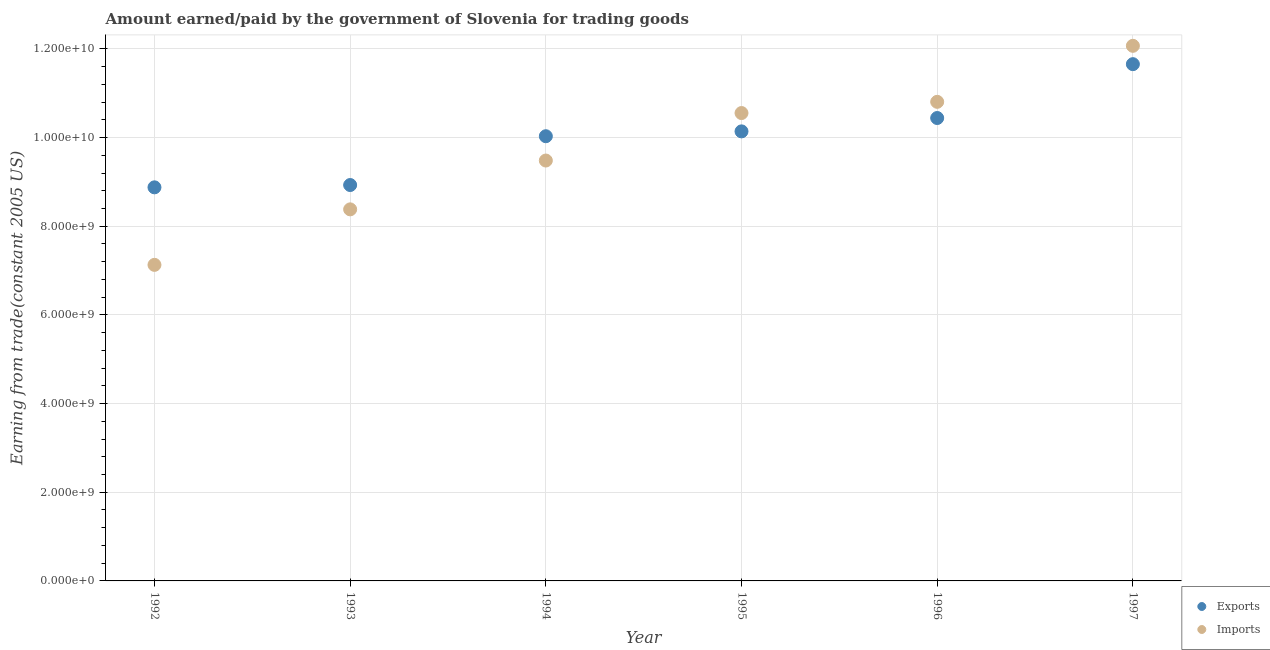How many different coloured dotlines are there?
Provide a succinct answer. 2. What is the amount earned from exports in 1997?
Keep it short and to the point. 1.17e+1. Across all years, what is the maximum amount paid for imports?
Offer a very short reply. 1.21e+1. Across all years, what is the minimum amount paid for imports?
Give a very brief answer. 7.13e+09. In which year was the amount earned from exports maximum?
Your answer should be compact. 1997. What is the total amount paid for imports in the graph?
Make the answer very short. 5.84e+1. What is the difference between the amount paid for imports in 1992 and that in 1994?
Provide a short and direct response. -2.35e+09. What is the difference between the amount earned from exports in 1993 and the amount paid for imports in 1992?
Your response must be concise. 1.80e+09. What is the average amount paid for imports per year?
Keep it short and to the point. 9.74e+09. In the year 1996, what is the difference between the amount paid for imports and amount earned from exports?
Keep it short and to the point. 3.65e+08. In how many years, is the amount paid for imports greater than 5600000000 US$?
Provide a succinct answer. 6. What is the ratio of the amount paid for imports in 1993 to that in 1994?
Give a very brief answer. 0.88. Is the amount paid for imports in 1992 less than that in 1995?
Provide a succinct answer. Yes. Is the difference between the amount earned from exports in 1995 and 1997 greater than the difference between the amount paid for imports in 1995 and 1997?
Offer a terse response. Yes. What is the difference between the highest and the second highest amount earned from exports?
Offer a very short reply. 1.21e+09. What is the difference between the highest and the lowest amount earned from exports?
Offer a terse response. 2.78e+09. Is the sum of the amount paid for imports in 1992 and 1993 greater than the maximum amount earned from exports across all years?
Your answer should be compact. Yes. Is the amount paid for imports strictly less than the amount earned from exports over the years?
Your response must be concise. No. How many dotlines are there?
Provide a short and direct response. 2. How many years are there in the graph?
Provide a short and direct response. 6. What is the difference between two consecutive major ticks on the Y-axis?
Your response must be concise. 2.00e+09. Are the values on the major ticks of Y-axis written in scientific E-notation?
Offer a very short reply. Yes. What is the title of the graph?
Keep it short and to the point. Amount earned/paid by the government of Slovenia for trading goods. What is the label or title of the X-axis?
Your response must be concise. Year. What is the label or title of the Y-axis?
Provide a succinct answer. Earning from trade(constant 2005 US). What is the Earning from trade(constant 2005 US) in Exports in 1992?
Provide a succinct answer. 8.88e+09. What is the Earning from trade(constant 2005 US) of Imports in 1992?
Offer a terse response. 7.13e+09. What is the Earning from trade(constant 2005 US) of Exports in 1993?
Ensure brevity in your answer.  8.93e+09. What is the Earning from trade(constant 2005 US) in Imports in 1993?
Ensure brevity in your answer.  8.38e+09. What is the Earning from trade(constant 2005 US) of Exports in 1994?
Provide a succinct answer. 1.00e+1. What is the Earning from trade(constant 2005 US) of Imports in 1994?
Offer a terse response. 9.48e+09. What is the Earning from trade(constant 2005 US) of Exports in 1995?
Offer a terse response. 1.01e+1. What is the Earning from trade(constant 2005 US) in Imports in 1995?
Provide a short and direct response. 1.06e+1. What is the Earning from trade(constant 2005 US) of Exports in 1996?
Make the answer very short. 1.04e+1. What is the Earning from trade(constant 2005 US) of Imports in 1996?
Your answer should be compact. 1.08e+1. What is the Earning from trade(constant 2005 US) of Exports in 1997?
Your answer should be compact. 1.17e+1. What is the Earning from trade(constant 2005 US) in Imports in 1997?
Keep it short and to the point. 1.21e+1. Across all years, what is the maximum Earning from trade(constant 2005 US) of Exports?
Ensure brevity in your answer.  1.17e+1. Across all years, what is the maximum Earning from trade(constant 2005 US) in Imports?
Offer a terse response. 1.21e+1. Across all years, what is the minimum Earning from trade(constant 2005 US) of Exports?
Offer a terse response. 8.88e+09. Across all years, what is the minimum Earning from trade(constant 2005 US) in Imports?
Make the answer very short. 7.13e+09. What is the total Earning from trade(constant 2005 US) of Exports in the graph?
Offer a very short reply. 6.01e+1. What is the total Earning from trade(constant 2005 US) of Imports in the graph?
Offer a terse response. 5.84e+1. What is the difference between the Earning from trade(constant 2005 US) in Exports in 1992 and that in 1993?
Offer a very short reply. -5.21e+07. What is the difference between the Earning from trade(constant 2005 US) of Imports in 1992 and that in 1993?
Give a very brief answer. -1.25e+09. What is the difference between the Earning from trade(constant 2005 US) of Exports in 1992 and that in 1994?
Ensure brevity in your answer.  -1.15e+09. What is the difference between the Earning from trade(constant 2005 US) of Imports in 1992 and that in 1994?
Your answer should be very brief. -2.35e+09. What is the difference between the Earning from trade(constant 2005 US) in Exports in 1992 and that in 1995?
Offer a very short reply. -1.26e+09. What is the difference between the Earning from trade(constant 2005 US) in Imports in 1992 and that in 1995?
Your answer should be compact. -3.42e+09. What is the difference between the Earning from trade(constant 2005 US) of Exports in 1992 and that in 1996?
Offer a terse response. -1.56e+09. What is the difference between the Earning from trade(constant 2005 US) of Imports in 1992 and that in 1996?
Make the answer very short. -3.68e+09. What is the difference between the Earning from trade(constant 2005 US) in Exports in 1992 and that in 1997?
Your answer should be compact. -2.78e+09. What is the difference between the Earning from trade(constant 2005 US) in Imports in 1992 and that in 1997?
Offer a very short reply. -4.94e+09. What is the difference between the Earning from trade(constant 2005 US) in Exports in 1993 and that in 1994?
Provide a short and direct response. -1.10e+09. What is the difference between the Earning from trade(constant 2005 US) of Imports in 1993 and that in 1994?
Make the answer very short. -1.10e+09. What is the difference between the Earning from trade(constant 2005 US) in Exports in 1993 and that in 1995?
Your answer should be very brief. -1.21e+09. What is the difference between the Earning from trade(constant 2005 US) in Imports in 1993 and that in 1995?
Provide a short and direct response. -2.17e+09. What is the difference between the Earning from trade(constant 2005 US) of Exports in 1993 and that in 1996?
Offer a terse response. -1.51e+09. What is the difference between the Earning from trade(constant 2005 US) in Imports in 1993 and that in 1996?
Ensure brevity in your answer.  -2.43e+09. What is the difference between the Earning from trade(constant 2005 US) of Exports in 1993 and that in 1997?
Your answer should be very brief. -2.73e+09. What is the difference between the Earning from trade(constant 2005 US) in Imports in 1993 and that in 1997?
Your response must be concise. -3.69e+09. What is the difference between the Earning from trade(constant 2005 US) in Exports in 1994 and that in 1995?
Give a very brief answer. -1.09e+08. What is the difference between the Earning from trade(constant 2005 US) in Imports in 1994 and that in 1995?
Give a very brief answer. -1.07e+09. What is the difference between the Earning from trade(constant 2005 US) of Exports in 1994 and that in 1996?
Provide a succinct answer. -4.11e+08. What is the difference between the Earning from trade(constant 2005 US) of Imports in 1994 and that in 1996?
Offer a terse response. -1.32e+09. What is the difference between the Earning from trade(constant 2005 US) in Exports in 1994 and that in 1997?
Ensure brevity in your answer.  -1.63e+09. What is the difference between the Earning from trade(constant 2005 US) of Imports in 1994 and that in 1997?
Provide a short and direct response. -2.59e+09. What is the difference between the Earning from trade(constant 2005 US) in Exports in 1995 and that in 1996?
Your answer should be very brief. -3.01e+08. What is the difference between the Earning from trade(constant 2005 US) in Imports in 1995 and that in 1996?
Provide a succinct answer. -2.53e+08. What is the difference between the Earning from trade(constant 2005 US) in Exports in 1995 and that in 1997?
Provide a short and direct response. -1.52e+09. What is the difference between the Earning from trade(constant 2005 US) in Imports in 1995 and that in 1997?
Your answer should be compact. -1.52e+09. What is the difference between the Earning from trade(constant 2005 US) of Exports in 1996 and that in 1997?
Your answer should be very brief. -1.21e+09. What is the difference between the Earning from trade(constant 2005 US) in Imports in 1996 and that in 1997?
Make the answer very short. -1.26e+09. What is the difference between the Earning from trade(constant 2005 US) in Exports in 1992 and the Earning from trade(constant 2005 US) in Imports in 1993?
Offer a terse response. 4.97e+08. What is the difference between the Earning from trade(constant 2005 US) in Exports in 1992 and the Earning from trade(constant 2005 US) in Imports in 1994?
Ensure brevity in your answer.  -6.05e+08. What is the difference between the Earning from trade(constant 2005 US) in Exports in 1992 and the Earning from trade(constant 2005 US) in Imports in 1995?
Offer a terse response. -1.68e+09. What is the difference between the Earning from trade(constant 2005 US) in Exports in 1992 and the Earning from trade(constant 2005 US) in Imports in 1996?
Make the answer very short. -1.93e+09. What is the difference between the Earning from trade(constant 2005 US) in Exports in 1992 and the Earning from trade(constant 2005 US) in Imports in 1997?
Your answer should be very brief. -3.19e+09. What is the difference between the Earning from trade(constant 2005 US) in Exports in 1993 and the Earning from trade(constant 2005 US) in Imports in 1994?
Ensure brevity in your answer.  -5.52e+08. What is the difference between the Earning from trade(constant 2005 US) of Exports in 1993 and the Earning from trade(constant 2005 US) of Imports in 1995?
Ensure brevity in your answer.  -1.62e+09. What is the difference between the Earning from trade(constant 2005 US) in Exports in 1993 and the Earning from trade(constant 2005 US) in Imports in 1996?
Your response must be concise. -1.88e+09. What is the difference between the Earning from trade(constant 2005 US) in Exports in 1993 and the Earning from trade(constant 2005 US) in Imports in 1997?
Your answer should be compact. -3.14e+09. What is the difference between the Earning from trade(constant 2005 US) of Exports in 1994 and the Earning from trade(constant 2005 US) of Imports in 1995?
Keep it short and to the point. -5.23e+08. What is the difference between the Earning from trade(constant 2005 US) of Exports in 1994 and the Earning from trade(constant 2005 US) of Imports in 1996?
Your answer should be very brief. -7.76e+08. What is the difference between the Earning from trade(constant 2005 US) in Exports in 1994 and the Earning from trade(constant 2005 US) in Imports in 1997?
Give a very brief answer. -2.04e+09. What is the difference between the Earning from trade(constant 2005 US) in Exports in 1995 and the Earning from trade(constant 2005 US) in Imports in 1996?
Give a very brief answer. -6.66e+08. What is the difference between the Earning from trade(constant 2005 US) in Exports in 1995 and the Earning from trade(constant 2005 US) in Imports in 1997?
Your answer should be compact. -1.93e+09. What is the difference between the Earning from trade(constant 2005 US) of Exports in 1996 and the Earning from trade(constant 2005 US) of Imports in 1997?
Keep it short and to the point. -1.63e+09. What is the average Earning from trade(constant 2005 US) of Exports per year?
Your response must be concise. 1.00e+1. What is the average Earning from trade(constant 2005 US) in Imports per year?
Give a very brief answer. 9.74e+09. In the year 1992, what is the difference between the Earning from trade(constant 2005 US) in Exports and Earning from trade(constant 2005 US) in Imports?
Provide a succinct answer. 1.75e+09. In the year 1993, what is the difference between the Earning from trade(constant 2005 US) in Exports and Earning from trade(constant 2005 US) in Imports?
Ensure brevity in your answer.  5.49e+08. In the year 1994, what is the difference between the Earning from trade(constant 2005 US) of Exports and Earning from trade(constant 2005 US) of Imports?
Offer a terse response. 5.48e+08. In the year 1995, what is the difference between the Earning from trade(constant 2005 US) in Exports and Earning from trade(constant 2005 US) in Imports?
Your answer should be very brief. -4.13e+08. In the year 1996, what is the difference between the Earning from trade(constant 2005 US) in Exports and Earning from trade(constant 2005 US) in Imports?
Your answer should be compact. -3.65e+08. In the year 1997, what is the difference between the Earning from trade(constant 2005 US) in Exports and Earning from trade(constant 2005 US) in Imports?
Your response must be concise. -4.13e+08. What is the ratio of the Earning from trade(constant 2005 US) in Imports in 1992 to that in 1993?
Give a very brief answer. 0.85. What is the ratio of the Earning from trade(constant 2005 US) in Exports in 1992 to that in 1994?
Make the answer very short. 0.89. What is the ratio of the Earning from trade(constant 2005 US) of Imports in 1992 to that in 1994?
Provide a succinct answer. 0.75. What is the ratio of the Earning from trade(constant 2005 US) of Exports in 1992 to that in 1995?
Provide a short and direct response. 0.88. What is the ratio of the Earning from trade(constant 2005 US) in Imports in 1992 to that in 1995?
Ensure brevity in your answer.  0.68. What is the ratio of the Earning from trade(constant 2005 US) of Exports in 1992 to that in 1996?
Ensure brevity in your answer.  0.85. What is the ratio of the Earning from trade(constant 2005 US) of Imports in 1992 to that in 1996?
Your response must be concise. 0.66. What is the ratio of the Earning from trade(constant 2005 US) in Exports in 1992 to that in 1997?
Your answer should be very brief. 0.76. What is the ratio of the Earning from trade(constant 2005 US) in Imports in 1992 to that in 1997?
Keep it short and to the point. 0.59. What is the ratio of the Earning from trade(constant 2005 US) of Exports in 1993 to that in 1994?
Your response must be concise. 0.89. What is the ratio of the Earning from trade(constant 2005 US) in Imports in 1993 to that in 1994?
Your answer should be very brief. 0.88. What is the ratio of the Earning from trade(constant 2005 US) of Exports in 1993 to that in 1995?
Offer a terse response. 0.88. What is the ratio of the Earning from trade(constant 2005 US) in Imports in 1993 to that in 1995?
Give a very brief answer. 0.79. What is the ratio of the Earning from trade(constant 2005 US) of Exports in 1993 to that in 1996?
Your answer should be very brief. 0.86. What is the ratio of the Earning from trade(constant 2005 US) in Imports in 1993 to that in 1996?
Your answer should be very brief. 0.78. What is the ratio of the Earning from trade(constant 2005 US) of Exports in 1993 to that in 1997?
Provide a succinct answer. 0.77. What is the ratio of the Earning from trade(constant 2005 US) of Imports in 1993 to that in 1997?
Make the answer very short. 0.69. What is the ratio of the Earning from trade(constant 2005 US) in Exports in 1994 to that in 1995?
Ensure brevity in your answer.  0.99. What is the ratio of the Earning from trade(constant 2005 US) in Imports in 1994 to that in 1995?
Provide a short and direct response. 0.9. What is the ratio of the Earning from trade(constant 2005 US) in Exports in 1994 to that in 1996?
Make the answer very short. 0.96. What is the ratio of the Earning from trade(constant 2005 US) in Imports in 1994 to that in 1996?
Your response must be concise. 0.88. What is the ratio of the Earning from trade(constant 2005 US) in Exports in 1994 to that in 1997?
Your answer should be compact. 0.86. What is the ratio of the Earning from trade(constant 2005 US) in Imports in 1994 to that in 1997?
Provide a short and direct response. 0.79. What is the ratio of the Earning from trade(constant 2005 US) in Exports in 1995 to that in 1996?
Give a very brief answer. 0.97. What is the ratio of the Earning from trade(constant 2005 US) in Imports in 1995 to that in 1996?
Make the answer very short. 0.98. What is the ratio of the Earning from trade(constant 2005 US) in Exports in 1995 to that in 1997?
Provide a short and direct response. 0.87. What is the ratio of the Earning from trade(constant 2005 US) of Imports in 1995 to that in 1997?
Offer a very short reply. 0.87. What is the ratio of the Earning from trade(constant 2005 US) of Exports in 1996 to that in 1997?
Ensure brevity in your answer.  0.9. What is the ratio of the Earning from trade(constant 2005 US) of Imports in 1996 to that in 1997?
Your response must be concise. 0.9. What is the difference between the highest and the second highest Earning from trade(constant 2005 US) in Exports?
Ensure brevity in your answer.  1.21e+09. What is the difference between the highest and the second highest Earning from trade(constant 2005 US) of Imports?
Offer a terse response. 1.26e+09. What is the difference between the highest and the lowest Earning from trade(constant 2005 US) in Exports?
Give a very brief answer. 2.78e+09. What is the difference between the highest and the lowest Earning from trade(constant 2005 US) of Imports?
Your response must be concise. 4.94e+09. 